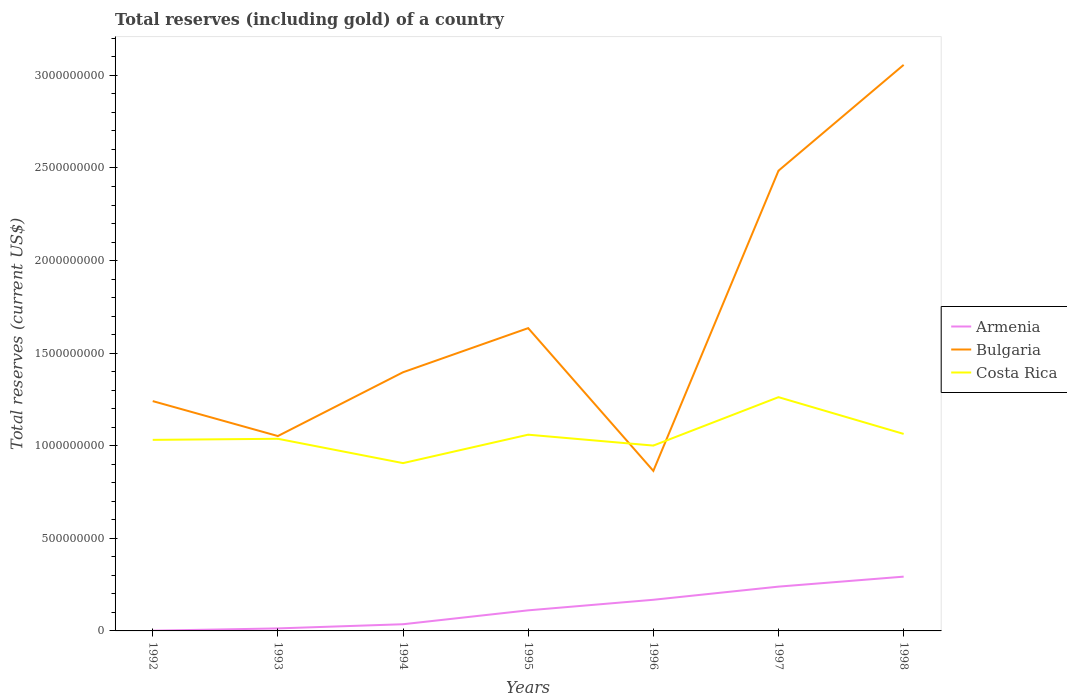How many different coloured lines are there?
Provide a short and direct response. 3. Does the line corresponding to Armenia intersect with the line corresponding to Bulgaria?
Ensure brevity in your answer.  No. Across all years, what is the maximum total reserves (including gold) in Armenia?
Offer a very short reply. 1.29e+06. What is the total total reserves (including gold) in Bulgaria in the graph?
Provide a succinct answer. 1.88e+08. What is the difference between the highest and the second highest total reserves (including gold) in Armenia?
Your answer should be compact. 2.92e+08. What is the difference between two consecutive major ticks on the Y-axis?
Offer a terse response. 5.00e+08. Are the values on the major ticks of Y-axis written in scientific E-notation?
Provide a short and direct response. No. Does the graph contain grids?
Give a very brief answer. No. Where does the legend appear in the graph?
Keep it short and to the point. Center right. How many legend labels are there?
Provide a succinct answer. 3. How are the legend labels stacked?
Offer a terse response. Vertical. What is the title of the graph?
Ensure brevity in your answer.  Total reserves (including gold) of a country. What is the label or title of the X-axis?
Provide a succinct answer. Years. What is the label or title of the Y-axis?
Offer a terse response. Total reserves (current US$). What is the Total reserves (current US$) of Armenia in 1992?
Offer a terse response. 1.29e+06. What is the Total reserves (current US$) in Bulgaria in 1992?
Offer a terse response. 1.24e+09. What is the Total reserves (current US$) in Costa Rica in 1992?
Give a very brief answer. 1.03e+09. What is the Total reserves (current US$) in Armenia in 1993?
Provide a short and direct response. 1.36e+07. What is the Total reserves (current US$) in Bulgaria in 1993?
Provide a short and direct response. 1.05e+09. What is the Total reserves (current US$) in Costa Rica in 1993?
Keep it short and to the point. 1.04e+09. What is the Total reserves (current US$) in Armenia in 1994?
Your answer should be very brief. 3.61e+07. What is the Total reserves (current US$) in Bulgaria in 1994?
Make the answer very short. 1.40e+09. What is the Total reserves (current US$) of Costa Rica in 1994?
Give a very brief answer. 9.06e+08. What is the Total reserves (current US$) in Armenia in 1995?
Keep it short and to the point. 1.11e+08. What is the Total reserves (current US$) of Bulgaria in 1995?
Keep it short and to the point. 1.64e+09. What is the Total reserves (current US$) of Costa Rica in 1995?
Keep it short and to the point. 1.06e+09. What is the Total reserves (current US$) of Armenia in 1996?
Give a very brief answer. 1.68e+08. What is the Total reserves (current US$) of Bulgaria in 1996?
Your response must be concise. 8.64e+08. What is the Total reserves (current US$) of Costa Rica in 1996?
Provide a short and direct response. 1.00e+09. What is the Total reserves (current US$) of Armenia in 1997?
Provide a short and direct response. 2.39e+08. What is the Total reserves (current US$) in Bulgaria in 1997?
Make the answer very short. 2.49e+09. What is the Total reserves (current US$) in Costa Rica in 1997?
Offer a very short reply. 1.26e+09. What is the Total reserves (current US$) in Armenia in 1998?
Keep it short and to the point. 2.93e+08. What is the Total reserves (current US$) of Bulgaria in 1998?
Ensure brevity in your answer.  3.06e+09. What is the Total reserves (current US$) in Costa Rica in 1998?
Give a very brief answer. 1.06e+09. Across all years, what is the maximum Total reserves (current US$) of Armenia?
Keep it short and to the point. 2.93e+08. Across all years, what is the maximum Total reserves (current US$) in Bulgaria?
Provide a succinct answer. 3.06e+09. Across all years, what is the maximum Total reserves (current US$) of Costa Rica?
Provide a succinct answer. 1.26e+09. Across all years, what is the minimum Total reserves (current US$) in Armenia?
Offer a terse response. 1.29e+06. Across all years, what is the minimum Total reserves (current US$) in Bulgaria?
Provide a short and direct response. 8.64e+08. Across all years, what is the minimum Total reserves (current US$) of Costa Rica?
Make the answer very short. 9.06e+08. What is the total Total reserves (current US$) in Armenia in the graph?
Give a very brief answer. 8.63e+08. What is the total Total reserves (current US$) in Bulgaria in the graph?
Your answer should be compact. 1.17e+1. What is the total Total reserves (current US$) of Costa Rica in the graph?
Keep it short and to the point. 7.36e+09. What is the difference between the Total reserves (current US$) in Armenia in 1992 and that in 1993?
Offer a very short reply. -1.23e+07. What is the difference between the Total reserves (current US$) in Bulgaria in 1992 and that in 1993?
Give a very brief answer. 1.89e+08. What is the difference between the Total reserves (current US$) in Costa Rica in 1992 and that in 1993?
Offer a very short reply. -5.81e+06. What is the difference between the Total reserves (current US$) of Armenia in 1992 and that in 1994?
Ensure brevity in your answer.  -3.48e+07. What is the difference between the Total reserves (current US$) of Bulgaria in 1992 and that in 1994?
Keep it short and to the point. -1.56e+08. What is the difference between the Total reserves (current US$) in Costa Rica in 1992 and that in 1994?
Provide a succinct answer. 1.26e+08. What is the difference between the Total reserves (current US$) in Armenia in 1992 and that in 1995?
Offer a very short reply. -1.10e+08. What is the difference between the Total reserves (current US$) in Bulgaria in 1992 and that in 1995?
Provide a short and direct response. -3.94e+08. What is the difference between the Total reserves (current US$) in Costa Rica in 1992 and that in 1995?
Offer a very short reply. -2.79e+07. What is the difference between the Total reserves (current US$) in Armenia in 1992 and that in 1996?
Give a very brief answer. -1.67e+08. What is the difference between the Total reserves (current US$) of Bulgaria in 1992 and that in 1996?
Your response must be concise. 3.77e+08. What is the difference between the Total reserves (current US$) of Costa Rica in 1992 and that in 1996?
Your response must be concise. 3.09e+07. What is the difference between the Total reserves (current US$) in Armenia in 1992 and that in 1997?
Make the answer very short. -2.38e+08. What is the difference between the Total reserves (current US$) in Bulgaria in 1992 and that in 1997?
Offer a very short reply. -1.24e+09. What is the difference between the Total reserves (current US$) of Costa Rica in 1992 and that in 1997?
Keep it short and to the point. -2.31e+08. What is the difference between the Total reserves (current US$) of Armenia in 1992 and that in 1998?
Your response must be concise. -2.92e+08. What is the difference between the Total reserves (current US$) of Bulgaria in 1992 and that in 1998?
Offer a very short reply. -1.82e+09. What is the difference between the Total reserves (current US$) of Costa Rica in 1992 and that in 1998?
Your answer should be very brief. -3.21e+07. What is the difference between the Total reserves (current US$) of Armenia in 1993 and that in 1994?
Make the answer very short. -2.25e+07. What is the difference between the Total reserves (current US$) in Bulgaria in 1993 and that in 1994?
Provide a short and direct response. -3.44e+08. What is the difference between the Total reserves (current US$) in Costa Rica in 1993 and that in 1994?
Offer a terse response. 1.31e+08. What is the difference between the Total reserves (current US$) in Armenia in 1993 and that in 1995?
Keep it short and to the point. -9.76e+07. What is the difference between the Total reserves (current US$) of Bulgaria in 1993 and that in 1995?
Provide a short and direct response. -5.83e+08. What is the difference between the Total reserves (current US$) of Costa Rica in 1993 and that in 1995?
Provide a succinct answer. -2.21e+07. What is the difference between the Total reserves (current US$) of Armenia in 1993 and that in 1996?
Ensure brevity in your answer.  -1.55e+08. What is the difference between the Total reserves (current US$) of Bulgaria in 1993 and that in 1996?
Offer a terse response. 1.88e+08. What is the difference between the Total reserves (current US$) in Costa Rica in 1993 and that in 1996?
Provide a short and direct response. 3.67e+07. What is the difference between the Total reserves (current US$) of Armenia in 1993 and that in 1997?
Your answer should be compact. -2.26e+08. What is the difference between the Total reserves (current US$) of Bulgaria in 1993 and that in 1997?
Ensure brevity in your answer.  -1.43e+09. What is the difference between the Total reserves (current US$) in Costa Rica in 1993 and that in 1997?
Provide a short and direct response. -2.25e+08. What is the difference between the Total reserves (current US$) in Armenia in 1993 and that in 1998?
Make the answer very short. -2.80e+08. What is the difference between the Total reserves (current US$) of Bulgaria in 1993 and that in 1998?
Your response must be concise. -2.00e+09. What is the difference between the Total reserves (current US$) in Costa Rica in 1993 and that in 1998?
Offer a terse response. -2.63e+07. What is the difference between the Total reserves (current US$) in Armenia in 1994 and that in 1995?
Give a very brief answer. -7.51e+07. What is the difference between the Total reserves (current US$) of Bulgaria in 1994 and that in 1995?
Provide a short and direct response. -2.38e+08. What is the difference between the Total reserves (current US$) of Costa Rica in 1994 and that in 1995?
Provide a short and direct response. -1.54e+08. What is the difference between the Total reserves (current US$) in Armenia in 1994 and that in 1996?
Provide a succinct answer. -1.32e+08. What is the difference between the Total reserves (current US$) in Bulgaria in 1994 and that in 1996?
Make the answer very short. 5.33e+08. What is the difference between the Total reserves (current US$) in Costa Rica in 1994 and that in 1996?
Keep it short and to the point. -9.47e+07. What is the difference between the Total reserves (current US$) in Armenia in 1994 and that in 1997?
Your answer should be compact. -2.03e+08. What is the difference between the Total reserves (current US$) in Bulgaria in 1994 and that in 1997?
Ensure brevity in your answer.  -1.09e+09. What is the difference between the Total reserves (current US$) of Costa Rica in 1994 and that in 1997?
Keep it short and to the point. -3.56e+08. What is the difference between the Total reserves (current US$) in Armenia in 1994 and that in 1998?
Your answer should be compact. -2.57e+08. What is the difference between the Total reserves (current US$) in Bulgaria in 1994 and that in 1998?
Make the answer very short. -1.66e+09. What is the difference between the Total reserves (current US$) in Costa Rica in 1994 and that in 1998?
Provide a short and direct response. -1.58e+08. What is the difference between the Total reserves (current US$) of Armenia in 1995 and that in 1996?
Your response must be concise. -5.70e+07. What is the difference between the Total reserves (current US$) of Bulgaria in 1995 and that in 1996?
Your response must be concise. 7.71e+08. What is the difference between the Total reserves (current US$) of Costa Rica in 1995 and that in 1996?
Make the answer very short. 5.88e+07. What is the difference between the Total reserves (current US$) of Armenia in 1995 and that in 1997?
Provide a short and direct response. -1.28e+08. What is the difference between the Total reserves (current US$) in Bulgaria in 1995 and that in 1997?
Make the answer very short. -8.50e+08. What is the difference between the Total reserves (current US$) of Costa Rica in 1995 and that in 1997?
Your answer should be compact. -2.03e+08. What is the difference between the Total reserves (current US$) in Armenia in 1995 and that in 1998?
Keep it short and to the point. -1.82e+08. What is the difference between the Total reserves (current US$) of Bulgaria in 1995 and that in 1998?
Give a very brief answer. -1.42e+09. What is the difference between the Total reserves (current US$) in Costa Rica in 1995 and that in 1998?
Your response must be concise. -4.18e+06. What is the difference between the Total reserves (current US$) in Armenia in 1996 and that in 1997?
Your answer should be compact. -7.10e+07. What is the difference between the Total reserves (current US$) of Bulgaria in 1996 and that in 1997?
Provide a succinct answer. -1.62e+09. What is the difference between the Total reserves (current US$) in Costa Rica in 1996 and that in 1997?
Your answer should be very brief. -2.61e+08. What is the difference between the Total reserves (current US$) of Armenia in 1996 and that in 1998?
Your answer should be very brief. -1.25e+08. What is the difference between the Total reserves (current US$) in Bulgaria in 1996 and that in 1998?
Offer a very short reply. -2.19e+09. What is the difference between the Total reserves (current US$) of Costa Rica in 1996 and that in 1998?
Offer a terse response. -6.30e+07. What is the difference between the Total reserves (current US$) of Armenia in 1997 and that in 1998?
Ensure brevity in your answer.  -5.39e+07. What is the difference between the Total reserves (current US$) of Bulgaria in 1997 and that in 1998?
Your response must be concise. -5.72e+08. What is the difference between the Total reserves (current US$) of Costa Rica in 1997 and that in 1998?
Provide a short and direct response. 1.98e+08. What is the difference between the Total reserves (current US$) of Armenia in 1992 and the Total reserves (current US$) of Bulgaria in 1993?
Make the answer very short. -1.05e+09. What is the difference between the Total reserves (current US$) in Armenia in 1992 and the Total reserves (current US$) in Costa Rica in 1993?
Provide a short and direct response. -1.04e+09. What is the difference between the Total reserves (current US$) in Bulgaria in 1992 and the Total reserves (current US$) in Costa Rica in 1993?
Ensure brevity in your answer.  2.03e+08. What is the difference between the Total reserves (current US$) in Armenia in 1992 and the Total reserves (current US$) in Bulgaria in 1994?
Make the answer very short. -1.40e+09. What is the difference between the Total reserves (current US$) of Armenia in 1992 and the Total reserves (current US$) of Costa Rica in 1994?
Your answer should be very brief. -9.05e+08. What is the difference between the Total reserves (current US$) of Bulgaria in 1992 and the Total reserves (current US$) of Costa Rica in 1994?
Your response must be concise. 3.35e+08. What is the difference between the Total reserves (current US$) of Armenia in 1992 and the Total reserves (current US$) of Bulgaria in 1995?
Make the answer very short. -1.63e+09. What is the difference between the Total reserves (current US$) of Armenia in 1992 and the Total reserves (current US$) of Costa Rica in 1995?
Offer a terse response. -1.06e+09. What is the difference between the Total reserves (current US$) in Bulgaria in 1992 and the Total reserves (current US$) in Costa Rica in 1995?
Your response must be concise. 1.81e+08. What is the difference between the Total reserves (current US$) of Armenia in 1992 and the Total reserves (current US$) of Bulgaria in 1996?
Your answer should be compact. -8.63e+08. What is the difference between the Total reserves (current US$) in Armenia in 1992 and the Total reserves (current US$) in Costa Rica in 1996?
Offer a terse response. -1.00e+09. What is the difference between the Total reserves (current US$) of Bulgaria in 1992 and the Total reserves (current US$) of Costa Rica in 1996?
Give a very brief answer. 2.40e+08. What is the difference between the Total reserves (current US$) of Armenia in 1992 and the Total reserves (current US$) of Bulgaria in 1997?
Provide a short and direct response. -2.48e+09. What is the difference between the Total reserves (current US$) in Armenia in 1992 and the Total reserves (current US$) in Costa Rica in 1997?
Give a very brief answer. -1.26e+09. What is the difference between the Total reserves (current US$) of Bulgaria in 1992 and the Total reserves (current US$) of Costa Rica in 1997?
Keep it short and to the point. -2.13e+07. What is the difference between the Total reserves (current US$) in Armenia in 1992 and the Total reserves (current US$) in Bulgaria in 1998?
Make the answer very short. -3.06e+09. What is the difference between the Total reserves (current US$) of Armenia in 1992 and the Total reserves (current US$) of Costa Rica in 1998?
Give a very brief answer. -1.06e+09. What is the difference between the Total reserves (current US$) of Bulgaria in 1992 and the Total reserves (current US$) of Costa Rica in 1998?
Keep it short and to the point. 1.77e+08. What is the difference between the Total reserves (current US$) of Armenia in 1993 and the Total reserves (current US$) of Bulgaria in 1994?
Your answer should be very brief. -1.38e+09. What is the difference between the Total reserves (current US$) of Armenia in 1993 and the Total reserves (current US$) of Costa Rica in 1994?
Ensure brevity in your answer.  -8.93e+08. What is the difference between the Total reserves (current US$) in Bulgaria in 1993 and the Total reserves (current US$) in Costa Rica in 1994?
Give a very brief answer. 1.46e+08. What is the difference between the Total reserves (current US$) in Armenia in 1993 and the Total reserves (current US$) in Bulgaria in 1995?
Your answer should be compact. -1.62e+09. What is the difference between the Total reserves (current US$) in Armenia in 1993 and the Total reserves (current US$) in Costa Rica in 1995?
Provide a succinct answer. -1.05e+09. What is the difference between the Total reserves (current US$) in Bulgaria in 1993 and the Total reserves (current US$) in Costa Rica in 1995?
Provide a succinct answer. -7.31e+06. What is the difference between the Total reserves (current US$) of Armenia in 1993 and the Total reserves (current US$) of Bulgaria in 1996?
Provide a short and direct response. -8.51e+08. What is the difference between the Total reserves (current US$) of Armenia in 1993 and the Total reserves (current US$) of Costa Rica in 1996?
Your answer should be very brief. -9.87e+08. What is the difference between the Total reserves (current US$) of Bulgaria in 1993 and the Total reserves (current US$) of Costa Rica in 1996?
Your answer should be very brief. 5.15e+07. What is the difference between the Total reserves (current US$) of Armenia in 1993 and the Total reserves (current US$) of Bulgaria in 1997?
Ensure brevity in your answer.  -2.47e+09. What is the difference between the Total reserves (current US$) of Armenia in 1993 and the Total reserves (current US$) of Costa Rica in 1997?
Give a very brief answer. -1.25e+09. What is the difference between the Total reserves (current US$) in Bulgaria in 1993 and the Total reserves (current US$) in Costa Rica in 1997?
Provide a short and direct response. -2.10e+08. What is the difference between the Total reserves (current US$) in Armenia in 1993 and the Total reserves (current US$) in Bulgaria in 1998?
Offer a very short reply. -3.04e+09. What is the difference between the Total reserves (current US$) of Armenia in 1993 and the Total reserves (current US$) of Costa Rica in 1998?
Give a very brief answer. -1.05e+09. What is the difference between the Total reserves (current US$) of Bulgaria in 1993 and the Total reserves (current US$) of Costa Rica in 1998?
Provide a succinct answer. -1.15e+07. What is the difference between the Total reserves (current US$) of Armenia in 1994 and the Total reserves (current US$) of Bulgaria in 1995?
Provide a short and direct response. -1.60e+09. What is the difference between the Total reserves (current US$) of Armenia in 1994 and the Total reserves (current US$) of Costa Rica in 1995?
Your response must be concise. -1.02e+09. What is the difference between the Total reserves (current US$) in Bulgaria in 1994 and the Total reserves (current US$) in Costa Rica in 1995?
Offer a very short reply. 3.37e+08. What is the difference between the Total reserves (current US$) of Armenia in 1994 and the Total reserves (current US$) of Bulgaria in 1996?
Provide a short and direct response. -8.28e+08. What is the difference between the Total reserves (current US$) in Armenia in 1994 and the Total reserves (current US$) in Costa Rica in 1996?
Offer a terse response. -9.65e+08. What is the difference between the Total reserves (current US$) in Bulgaria in 1994 and the Total reserves (current US$) in Costa Rica in 1996?
Provide a succinct answer. 3.96e+08. What is the difference between the Total reserves (current US$) in Armenia in 1994 and the Total reserves (current US$) in Bulgaria in 1997?
Ensure brevity in your answer.  -2.45e+09. What is the difference between the Total reserves (current US$) in Armenia in 1994 and the Total reserves (current US$) in Costa Rica in 1997?
Give a very brief answer. -1.23e+09. What is the difference between the Total reserves (current US$) of Bulgaria in 1994 and the Total reserves (current US$) of Costa Rica in 1997?
Provide a short and direct response. 1.35e+08. What is the difference between the Total reserves (current US$) in Armenia in 1994 and the Total reserves (current US$) in Bulgaria in 1998?
Give a very brief answer. -3.02e+09. What is the difference between the Total reserves (current US$) in Armenia in 1994 and the Total reserves (current US$) in Costa Rica in 1998?
Offer a very short reply. -1.03e+09. What is the difference between the Total reserves (current US$) in Bulgaria in 1994 and the Total reserves (current US$) in Costa Rica in 1998?
Ensure brevity in your answer.  3.33e+08. What is the difference between the Total reserves (current US$) in Armenia in 1995 and the Total reserves (current US$) in Bulgaria in 1996?
Your response must be concise. -7.53e+08. What is the difference between the Total reserves (current US$) in Armenia in 1995 and the Total reserves (current US$) in Costa Rica in 1996?
Your answer should be compact. -8.90e+08. What is the difference between the Total reserves (current US$) in Bulgaria in 1995 and the Total reserves (current US$) in Costa Rica in 1996?
Keep it short and to the point. 6.34e+08. What is the difference between the Total reserves (current US$) in Armenia in 1995 and the Total reserves (current US$) in Bulgaria in 1997?
Make the answer very short. -2.37e+09. What is the difference between the Total reserves (current US$) of Armenia in 1995 and the Total reserves (current US$) of Costa Rica in 1997?
Your answer should be compact. -1.15e+09. What is the difference between the Total reserves (current US$) of Bulgaria in 1995 and the Total reserves (current US$) of Costa Rica in 1997?
Your response must be concise. 3.73e+08. What is the difference between the Total reserves (current US$) in Armenia in 1995 and the Total reserves (current US$) in Bulgaria in 1998?
Give a very brief answer. -2.95e+09. What is the difference between the Total reserves (current US$) of Armenia in 1995 and the Total reserves (current US$) of Costa Rica in 1998?
Offer a very short reply. -9.53e+08. What is the difference between the Total reserves (current US$) in Bulgaria in 1995 and the Total reserves (current US$) in Costa Rica in 1998?
Your answer should be compact. 5.71e+08. What is the difference between the Total reserves (current US$) of Armenia in 1996 and the Total reserves (current US$) of Bulgaria in 1997?
Ensure brevity in your answer.  -2.32e+09. What is the difference between the Total reserves (current US$) of Armenia in 1996 and the Total reserves (current US$) of Costa Rica in 1997?
Provide a short and direct response. -1.09e+09. What is the difference between the Total reserves (current US$) in Bulgaria in 1996 and the Total reserves (current US$) in Costa Rica in 1997?
Give a very brief answer. -3.98e+08. What is the difference between the Total reserves (current US$) of Armenia in 1996 and the Total reserves (current US$) of Bulgaria in 1998?
Your answer should be compact. -2.89e+09. What is the difference between the Total reserves (current US$) in Armenia in 1996 and the Total reserves (current US$) in Costa Rica in 1998?
Ensure brevity in your answer.  -8.96e+08. What is the difference between the Total reserves (current US$) of Bulgaria in 1996 and the Total reserves (current US$) of Costa Rica in 1998?
Your answer should be compact. -2.00e+08. What is the difference between the Total reserves (current US$) in Armenia in 1997 and the Total reserves (current US$) in Bulgaria in 1998?
Make the answer very short. -2.82e+09. What is the difference between the Total reserves (current US$) in Armenia in 1997 and the Total reserves (current US$) in Costa Rica in 1998?
Your answer should be compact. -8.25e+08. What is the difference between the Total reserves (current US$) of Bulgaria in 1997 and the Total reserves (current US$) of Costa Rica in 1998?
Make the answer very short. 1.42e+09. What is the average Total reserves (current US$) of Armenia per year?
Provide a succinct answer. 1.23e+08. What is the average Total reserves (current US$) in Bulgaria per year?
Provide a short and direct response. 1.68e+09. What is the average Total reserves (current US$) of Costa Rica per year?
Your answer should be compact. 1.05e+09. In the year 1992, what is the difference between the Total reserves (current US$) of Armenia and Total reserves (current US$) of Bulgaria?
Provide a short and direct response. -1.24e+09. In the year 1992, what is the difference between the Total reserves (current US$) of Armenia and Total reserves (current US$) of Costa Rica?
Your answer should be compact. -1.03e+09. In the year 1992, what is the difference between the Total reserves (current US$) in Bulgaria and Total reserves (current US$) in Costa Rica?
Provide a succinct answer. 2.09e+08. In the year 1993, what is the difference between the Total reserves (current US$) of Armenia and Total reserves (current US$) of Bulgaria?
Your answer should be very brief. -1.04e+09. In the year 1993, what is the difference between the Total reserves (current US$) in Armenia and Total reserves (current US$) in Costa Rica?
Your answer should be compact. -1.02e+09. In the year 1993, what is the difference between the Total reserves (current US$) of Bulgaria and Total reserves (current US$) of Costa Rica?
Keep it short and to the point. 1.48e+07. In the year 1994, what is the difference between the Total reserves (current US$) of Armenia and Total reserves (current US$) of Bulgaria?
Provide a succinct answer. -1.36e+09. In the year 1994, what is the difference between the Total reserves (current US$) of Armenia and Total reserves (current US$) of Costa Rica?
Your answer should be very brief. -8.70e+08. In the year 1994, what is the difference between the Total reserves (current US$) of Bulgaria and Total reserves (current US$) of Costa Rica?
Your answer should be very brief. 4.91e+08. In the year 1995, what is the difference between the Total reserves (current US$) in Armenia and Total reserves (current US$) in Bulgaria?
Ensure brevity in your answer.  -1.52e+09. In the year 1995, what is the difference between the Total reserves (current US$) of Armenia and Total reserves (current US$) of Costa Rica?
Provide a short and direct response. -9.49e+08. In the year 1995, what is the difference between the Total reserves (current US$) in Bulgaria and Total reserves (current US$) in Costa Rica?
Your response must be concise. 5.75e+08. In the year 1996, what is the difference between the Total reserves (current US$) of Armenia and Total reserves (current US$) of Bulgaria?
Provide a succinct answer. -6.96e+08. In the year 1996, what is the difference between the Total reserves (current US$) of Armenia and Total reserves (current US$) of Costa Rica?
Give a very brief answer. -8.33e+08. In the year 1996, what is the difference between the Total reserves (current US$) of Bulgaria and Total reserves (current US$) of Costa Rica?
Your answer should be very brief. -1.37e+08. In the year 1997, what is the difference between the Total reserves (current US$) of Armenia and Total reserves (current US$) of Bulgaria?
Provide a succinct answer. -2.25e+09. In the year 1997, what is the difference between the Total reserves (current US$) in Armenia and Total reserves (current US$) in Costa Rica?
Your answer should be compact. -1.02e+09. In the year 1997, what is the difference between the Total reserves (current US$) in Bulgaria and Total reserves (current US$) in Costa Rica?
Ensure brevity in your answer.  1.22e+09. In the year 1998, what is the difference between the Total reserves (current US$) of Armenia and Total reserves (current US$) of Bulgaria?
Offer a terse response. -2.76e+09. In the year 1998, what is the difference between the Total reserves (current US$) of Armenia and Total reserves (current US$) of Costa Rica?
Give a very brief answer. -7.71e+08. In the year 1998, what is the difference between the Total reserves (current US$) in Bulgaria and Total reserves (current US$) in Costa Rica?
Provide a short and direct response. 1.99e+09. What is the ratio of the Total reserves (current US$) in Armenia in 1992 to that in 1993?
Ensure brevity in your answer.  0.1. What is the ratio of the Total reserves (current US$) of Bulgaria in 1992 to that in 1993?
Your answer should be compact. 1.18. What is the ratio of the Total reserves (current US$) of Armenia in 1992 to that in 1994?
Offer a very short reply. 0.04. What is the ratio of the Total reserves (current US$) of Bulgaria in 1992 to that in 1994?
Offer a terse response. 0.89. What is the ratio of the Total reserves (current US$) in Costa Rica in 1992 to that in 1994?
Keep it short and to the point. 1.14. What is the ratio of the Total reserves (current US$) in Armenia in 1992 to that in 1995?
Keep it short and to the point. 0.01. What is the ratio of the Total reserves (current US$) of Bulgaria in 1992 to that in 1995?
Provide a short and direct response. 0.76. What is the ratio of the Total reserves (current US$) of Costa Rica in 1992 to that in 1995?
Keep it short and to the point. 0.97. What is the ratio of the Total reserves (current US$) of Armenia in 1992 to that in 1996?
Your answer should be very brief. 0.01. What is the ratio of the Total reserves (current US$) in Bulgaria in 1992 to that in 1996?
Your response must be concise. 1.44. What is the ratio of the Total reserves (current US$) of Costa Rica in 1992 to that in 1996?
Provide a succinct answer. 1.03. What is the ratio of the Total reserves (current US$) in Armenia in 1992 to that in 1997?
Provide a succinct answer. 0.01. What is the ratio of the Total reserves (current US$) in Bulgaria in 1992 to that in 1997?
Your answer should be compact. 0.5. What is the ratio of the Total reserves (current US$) of Costa Rica in 1992 to that in 1997?
Provide a short and direct response. 0.82. What is the ratio of the Total reserves (current US$) of Armenia in 1992 to that in 1998?
Provide a short and direct response. 0. What is the ratio of the Total reserves (current US$) of Bulgaria in 1992 to that in 1998?
Your response must be concise. 0.41. What is the ratio of the Total reserves (current US$) of Costa Rica in 1992 to that in 1998?
Provide a short and direct response. 0.97. What is the ratio of the Total reserves (current US$) in Armenia in 1993 to that in 1994?
Keep it short and to the point. 0.38. What is the ratio of the Total reserves (current US$) of Bulgaria in 1993 to that in 1994?
Provide a short and direct response. 0.75. What is the ratio of the Total reserves (current US$) of Costa Rica in 1993 to that in 1994?
Provide a short and direct response. 1.15. What is the ratio of the Total reserves (current US$) in Armenia in 1993 to that in 1995?
Your answer should be compact. 0.12. What is the ratio of the Total reserves (current US$) in Bulgaria in 1993 to that in 1995?
Ensure brevity in your answer.  0.64. What is the ratio of the Total reserves (current US$) in Costa Rica in 1993 to that in 1995?
Keep it short and to the point. 0.98. What is the ratio of the Total reserves (current US$) of Armenia in 1993 to that in 1996?
Offer a terse response. 0.08. What is the ratio of the Total reserves (current US$) of Bulgaria in 1993 to that in 1996?
Keep it short and to the point. 1.22. What is the ratio of the Total reserves (current US$) of Costa Rica in 1993 to that in 1996?
Your response must be concise. 1.04. What is the ratio of the Total reserves (current US$) in Armenia in 1993 to that in 1997?
Give a very brief answer. 0.06. What is the ratio of the Total reserves (current US$) of Bulgaria in 1993 to that in 1997?
Make the answer very short. 0.42. What is the ratio of the Total reserves (current US$) of Costa Rica in 1993 to that in 1997?
Your answer should be compact. 0.82. What is the ratio of the Total reserves (current US$) in Armenia in 1993 to that in 1998?
Make the answer very short. 0.05. What is the ratio of the Total reserves (current US$) of Bulgaria in 1993 to that in 1998?
Keep it short and to the point. 0.34. What is the ratio of the Total reserves (current US$) of Costa Rica in 1993 to that in 1998?
Offer a terse response. 0.98. What is the ratio of the Total reserves (current US$) in Armenia in 1994 to that in 1995?
Your response must be concise. 0.32. What is the ratio of the Total reserves (current US$) of Bulgaria in 1994 to that in 1995?
Your answer should be very brief. 0.85. What is the ratio of the Total reserves (current US$) of Costa Rica in 1994 to that in 1995?
Provide a short and direct response. 0.86. What is the ratio of the Total reserves (current US$) in Armenia in 1994 to that in 1996?
Provide a succinct answer. 0.21. What is the ratio of the Total reserves (current US$) of Bulgaria in 1994 to that in 1996?
Keep it short and to the point. 1.62. What is the ratio of the Total reserves (current US$) in Costa Rica in 1994 to that in 1996?
Provide a short and direct response. 0.91. What is the ratio of the Total reserves (current US$) of Armenia in 1994 to that in 1997?
Keep it short and to the point. 0.15. What is the ratio of the Total reserves (current US$) of Bulgaria in 1994 to that in 1997?
Provide a succinct answer. 0.56. What is the ratio of the Total reserves (current US$) of Costa Rica in 1994 to that in 1997?
Offer a terse response. 0.72. What is the ratio of the Total reserves (current US$) of Armenia in 1994 to that in 1998?
Offer a very short reply. 0.12. What is the ratio of the Total reserves (current US$) of Bulgaria in 1994 to that in 1998?
Ensure brevity in your answer.  0.46. What is the ratio of the Total reserves (current US$) of Costa Rica in 1994 to that in 1998?
Make the answer very short. 0.85. What is the ratio of the Total reserves (current US$) of Armenia in 1995 to that in 1996?
Your response must be concise. 0.66. What is the ratio of the Total reserves (current US$) in Bulgaria in 1995 to that in 1996?
Provide a succinct answer. 1.89. What is the ratio of the Total reserves (current US$) of Costa Rica in 1995 to that in 1996?
Keep it short and to the point. 1.06. What is the ratio of the Total reserves (current US$) in Armenia in 1995 to that in 1997?
Make the answer very short. 0.46. What is the ratio of the Total reserves (current US$) of Bulgaria in 1995 to that in 1997?
Keep it short and to the point. 0.66. What is the ratio of the Total reserves (current US$) of Costa Rica in 1995 to that in 1997?
Your answer should be very brief. 0.84. What is the ratio of the Total reserves (current US$) in Armenia in 1995 to that in 1998?
Your response must be concise. 0.38. What is the ratio of the Total reserves (current US$) of Bulgaria in 1995 to that in 1998?
Provide a succinct answer. 0.53. What is the ratio of the Total reserves (current US$) in Costa Rica in 1995 to that in 1998?
Provide a short and direct response. 1. What is the ratio of the Total reserves (current US$) in Armenia in 1996 to that in 1997?
Your answer should be compact. 0.7. What is the ratio of the Total reserves (current US$) of Bulgaria in 1996 to that in 1997?
Your answer should be very brief. 0.35. What is the ratio of the Total reserves (current US$) in Costa Rica in 1996 to that in 1997?
Provide a short and direct response. 0.79. What is the ratio of the Total reserves (current US$) in Armenia in 1996 to that in 1998?
Make the answer very short. 0.57. What is the ratio of the Total reserves (current US$) in Bulgaria in 1996 to that in 1998?
Offer a very short reply. 0.28. What is the ratio of the Total reserves (current US$) in Costa Rica in 1996 to that in 1998?
Your answer should be compact. 0.94. What is the ratio of the Total reserves (current US$) of Armenia in 1997 to that in 1998?
Make the answer very short. 0.82. What is the ratio of the Total reserves (current US$) of Bulgaria in 1997 to that in 1998?
Offer a very short reply. 0.81. What is the ratio of the Total reserves (current US$) of Costa Rica in 1997 to that in 1998?
Give a very brief answer. 1.19. What is the difference between the highest and the second highest Total reserves (current US$) of Armenia?
Make the answer very short. 5.39e+07. What is the difference between the highest and the second highest Total reserves (current US$) of Bulgaria?
Your response must be concise. 5.72e+08. What is the difference between the highest and the second highest Total reserves (current US$) of Costa Rica?
Give a very brief answer. 1.98e+08. What is the difference between the highest and the lowest Total reserves (current US$) in Armenia?
Provide a short and direct response. 2.92e+08. What is the difference between the highest and the lowest Total reserves (current US$) in Bulgaria?
Your answer should be compact. 2.19e+09. What is the difference between the highest and the lowest Total reserves (current US$) in Costa Rica?
Make the answer very short. 3.56e+08. 